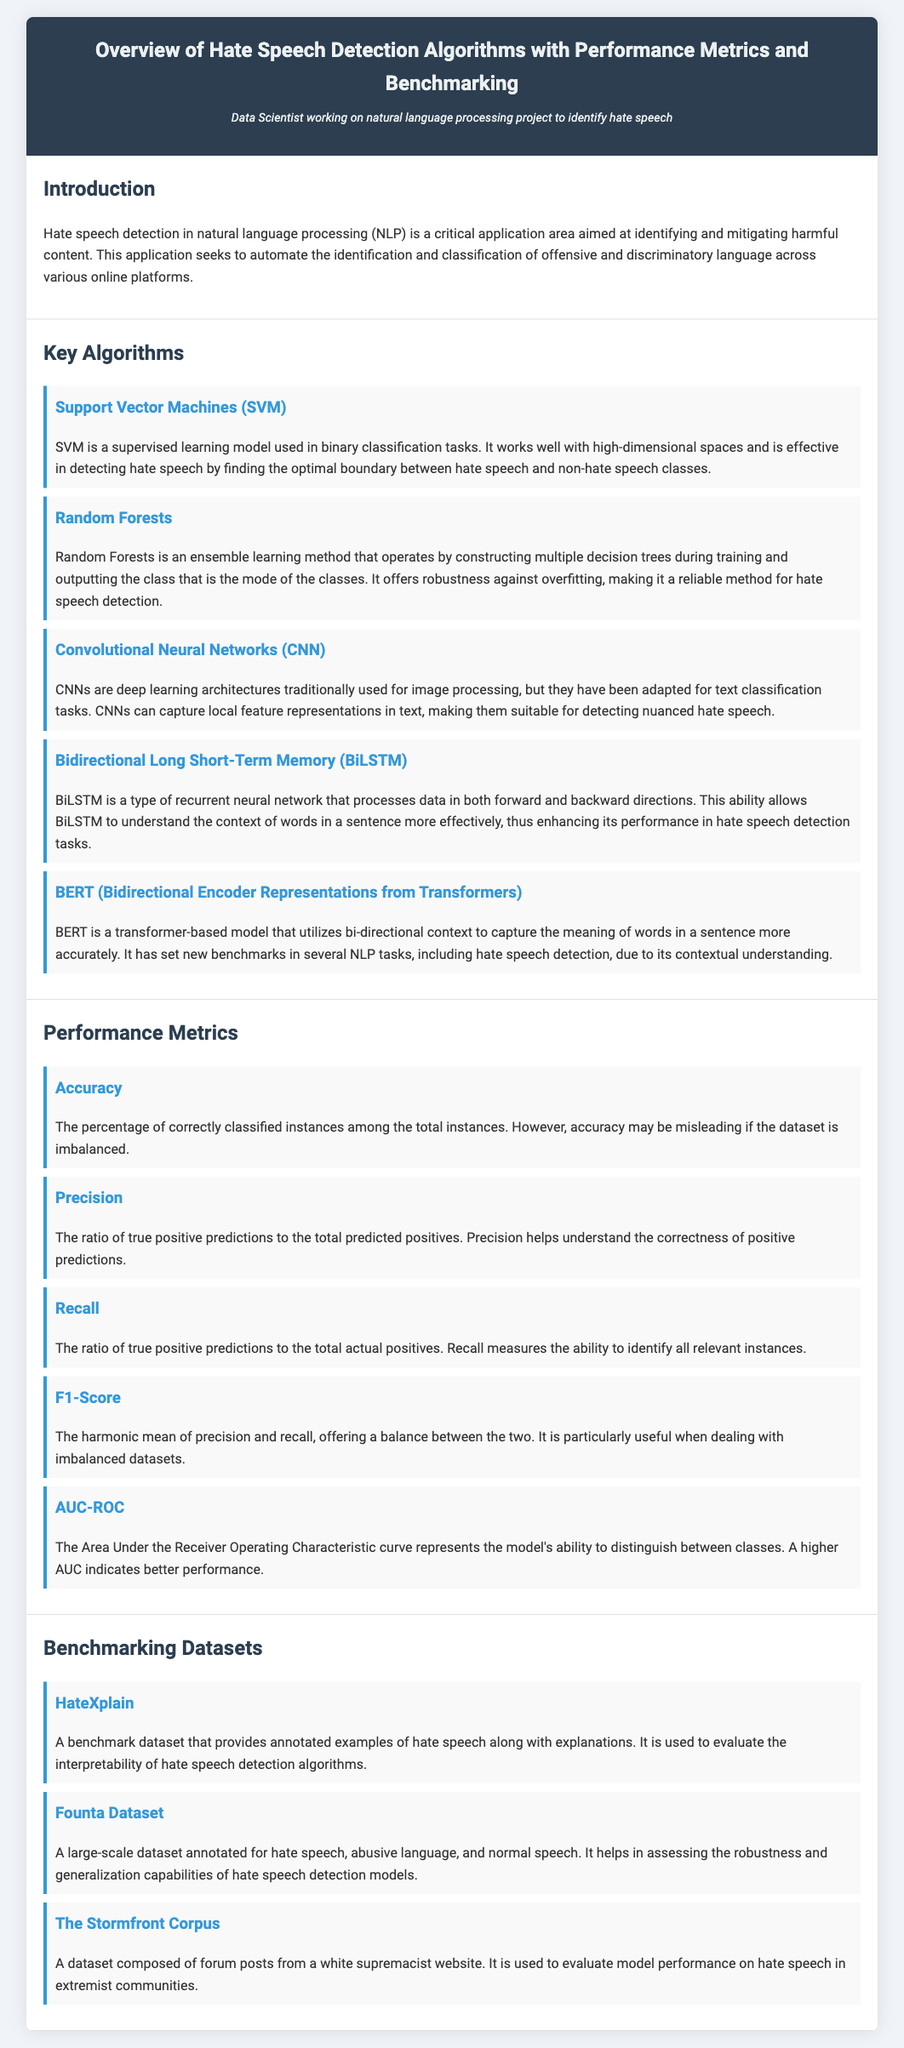what is the title of the document? The title of the document is located in the header section, which provides the main subject of the document.
Answer: Overview of Hate Speech Detection Algorithms with Performance Metrics and Benchmarking who is the intended audience of this document? The intended audience is mentioned below the title in a persona description, indicating who the main user of the document is.
Answer: Data Scientist working on natural language processing project to identify hate speech which algorithm is known for its robustness against overfitting? This information can be found in the section discussing key algorithms, specifically highlighting one method's characteristics.
Answer: Random Forests what performance metric measures the ability to identify all relevant instances? The relevant performance metric can be found in the metrics section, where different metrics are defined and their purposes stated.
Answer: Recall which dataset is specifically used for evaluating model performance on hate speech in extremist communities? This dataset is mentioned in the benchmarking datasets section specifically for its unique nature and focus area.
Answer: The Stormfront Corpus what is the harmonic mean of precision and recall? This concept is explained in the performance metrics section under the corresponding metric, indicating its mathematical relation.
Answer: F1-Score how many key algorithms are listed in the document? This information can be derived by counting the number of algorithms described in the key algorithms section.
Answer: Five what does AUC stand for in performance metrics? The acronym AUC is used within the performance metrics section where this metric is explained.
Answer: Area Under the Curve 